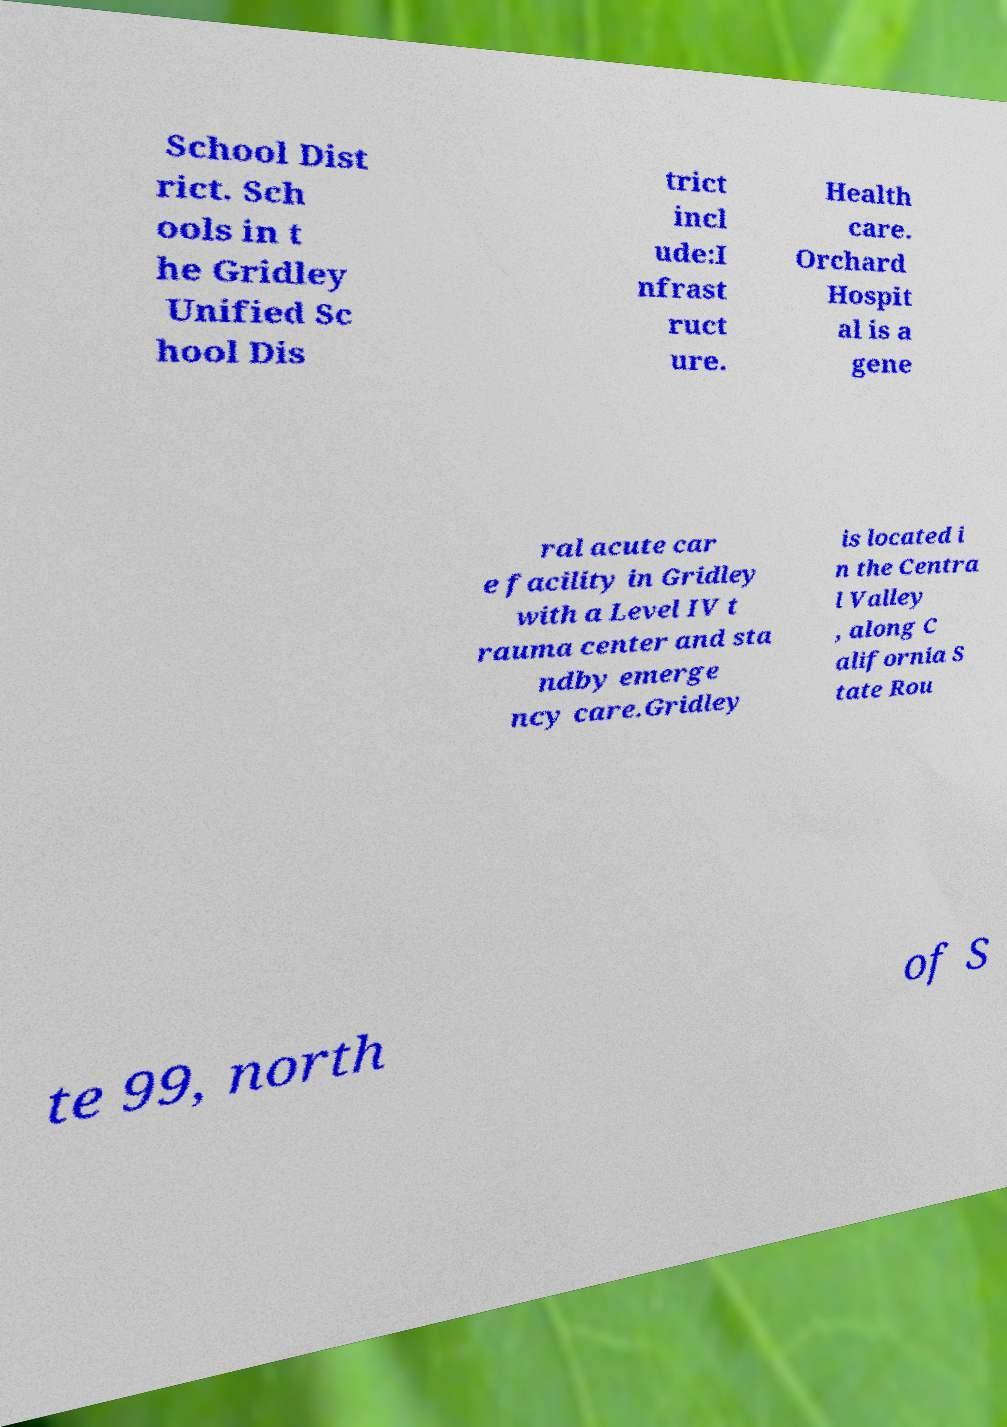I need the written content from this picture converted into text. Can you do that? School Dist rict. Sch ools in t he Gridley Unified Sc hool Dis trict incl ude:I nfrast ruct ure. Health care. Orchard Hospit al is a gene ral acute car e facility in Gridley with a Level IV t rauma center and sta ndby emerge ncy care.Gridley is located i n the Centra l Valley , along C alifornia S tate Rou te 99, north of S 